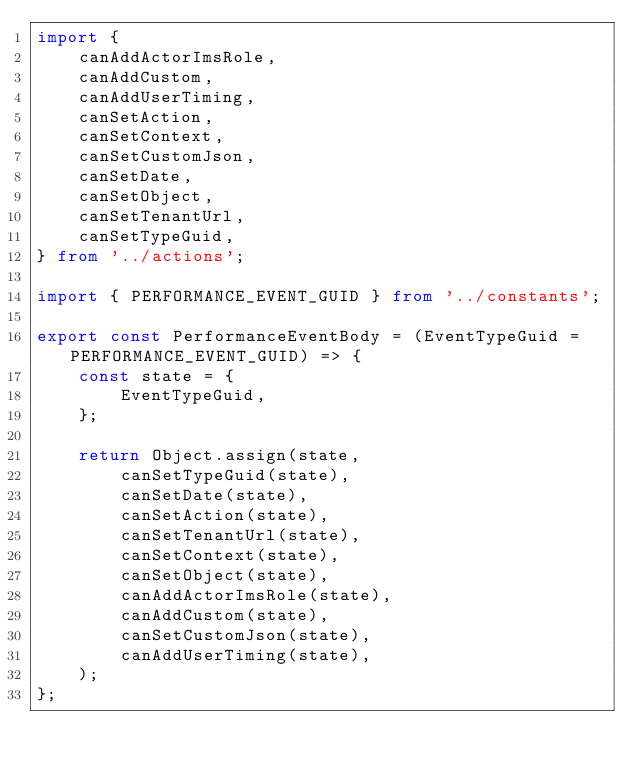<code> <loc_0><loc_0><loc_500><loc_500><_TypeScript_>import {
    canAddActorImsRole,
    canAddCustom,
    canAddUserTiming,
    canSetAction,
    canSetContext,
    canSetCustomJson,
    canSetDate,
    canSetObject,
    canSetTenantUrl,
    canSetTypeGuid,
} from '../actions';

import { PERFORMANCE_EVENT_GUID } from '../constants';

export const PerformanceEventBody = (EventTypeGuid = PERFORMANCE_EVENT_GUID) => {
    const state = {
        EventTypeGuid,
    };

    return Object.assign(state,
        canSetTypeGuid(state),
        canSetDate(state),
        canSetAction(state),
        canSetTenantUrl(state),
        canSetContext(state),
        canSetObject(state),
        canAddActorImsRole(state),
        canAddCustom(state),
        canSetCustomJson(state),
        canAddUserTiming(state),
    );
};
</code> 